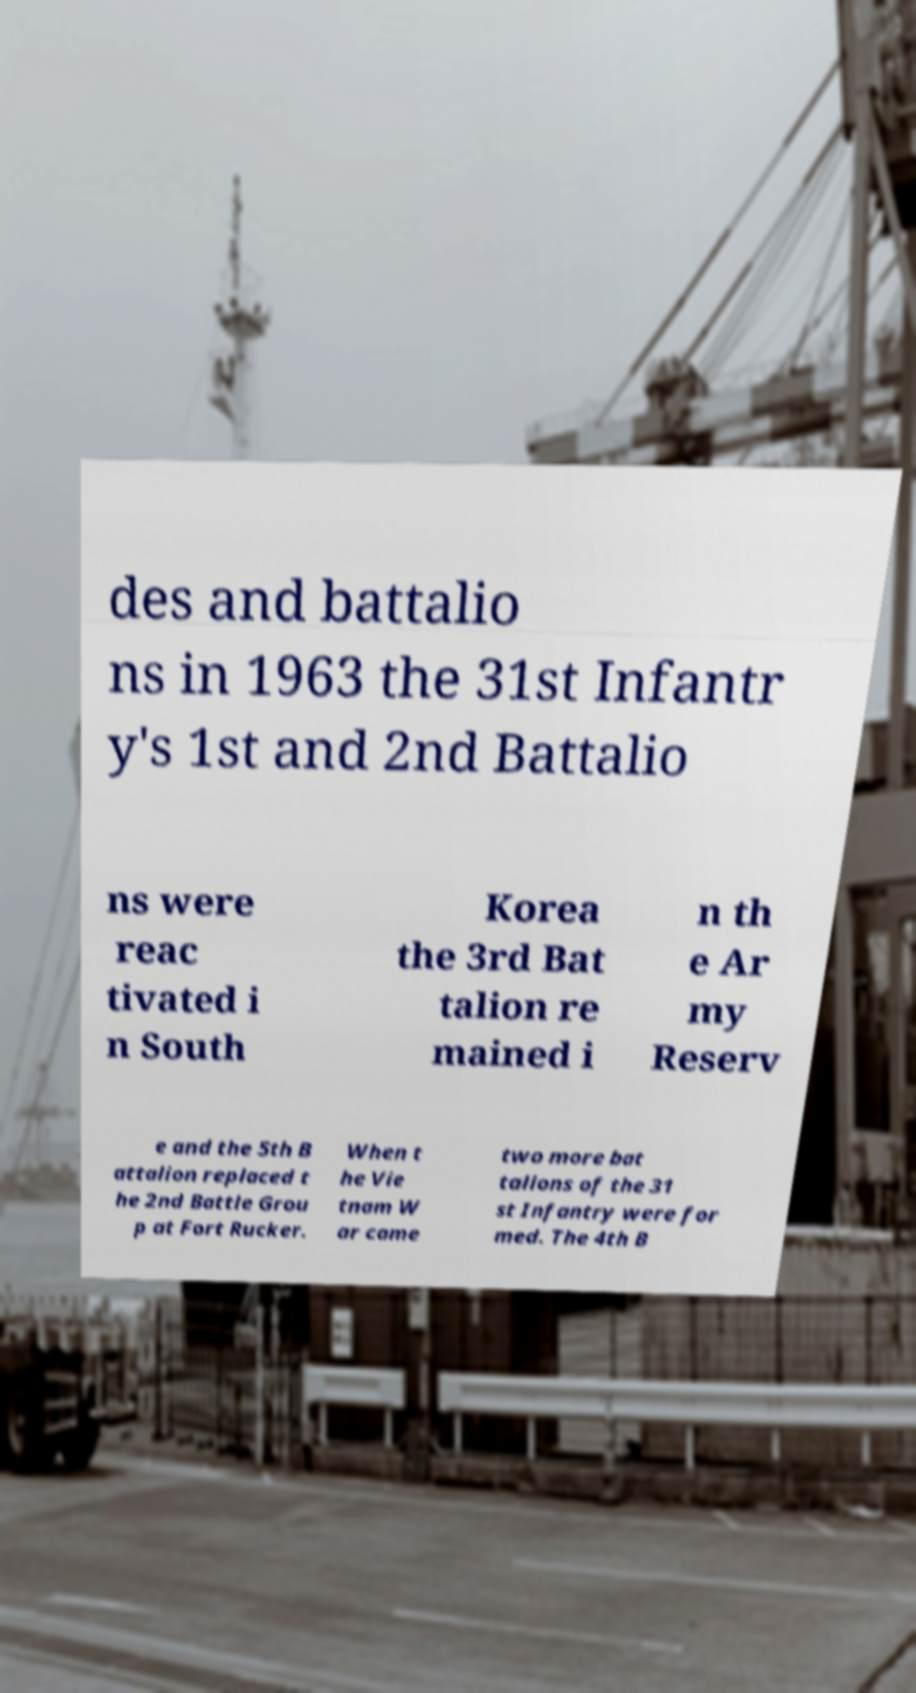Can you accurately transcribe the text from the provided image for me? des and battalio ns in 1963 the 31st Infantr y's 1st and 2nd Battalio ns were reac tivated i n South Korea the 3rd Bat talion re mained i n th e Ar my Reserv e and the 5th B attalion replaced t he 2nd Battle Grou p at Fort Rucker. When t he Vie tnam W ar came two more bat talions of the 31 st Infantry were for med. The 4th B 